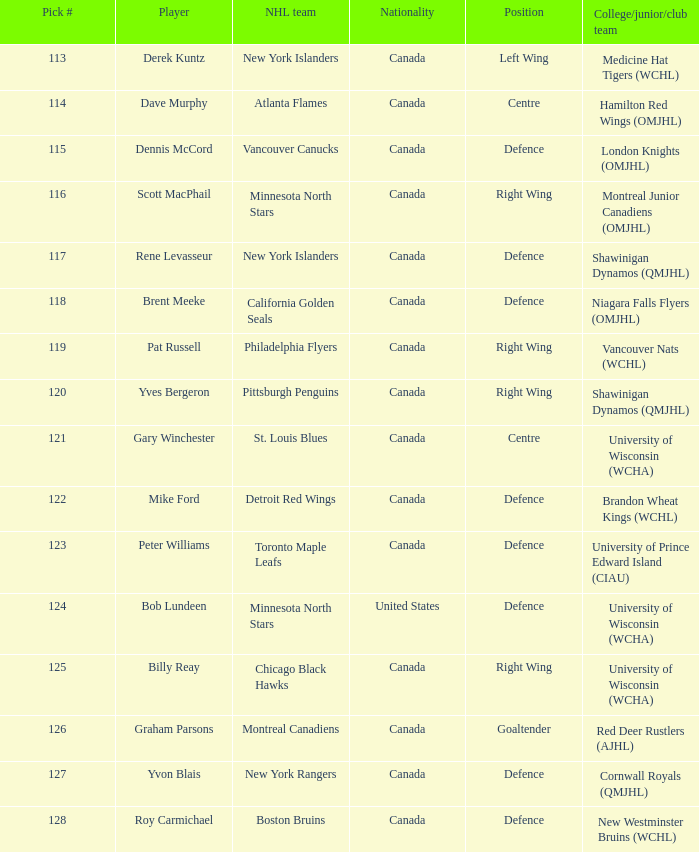Name the position for pick number 128 Defence. 